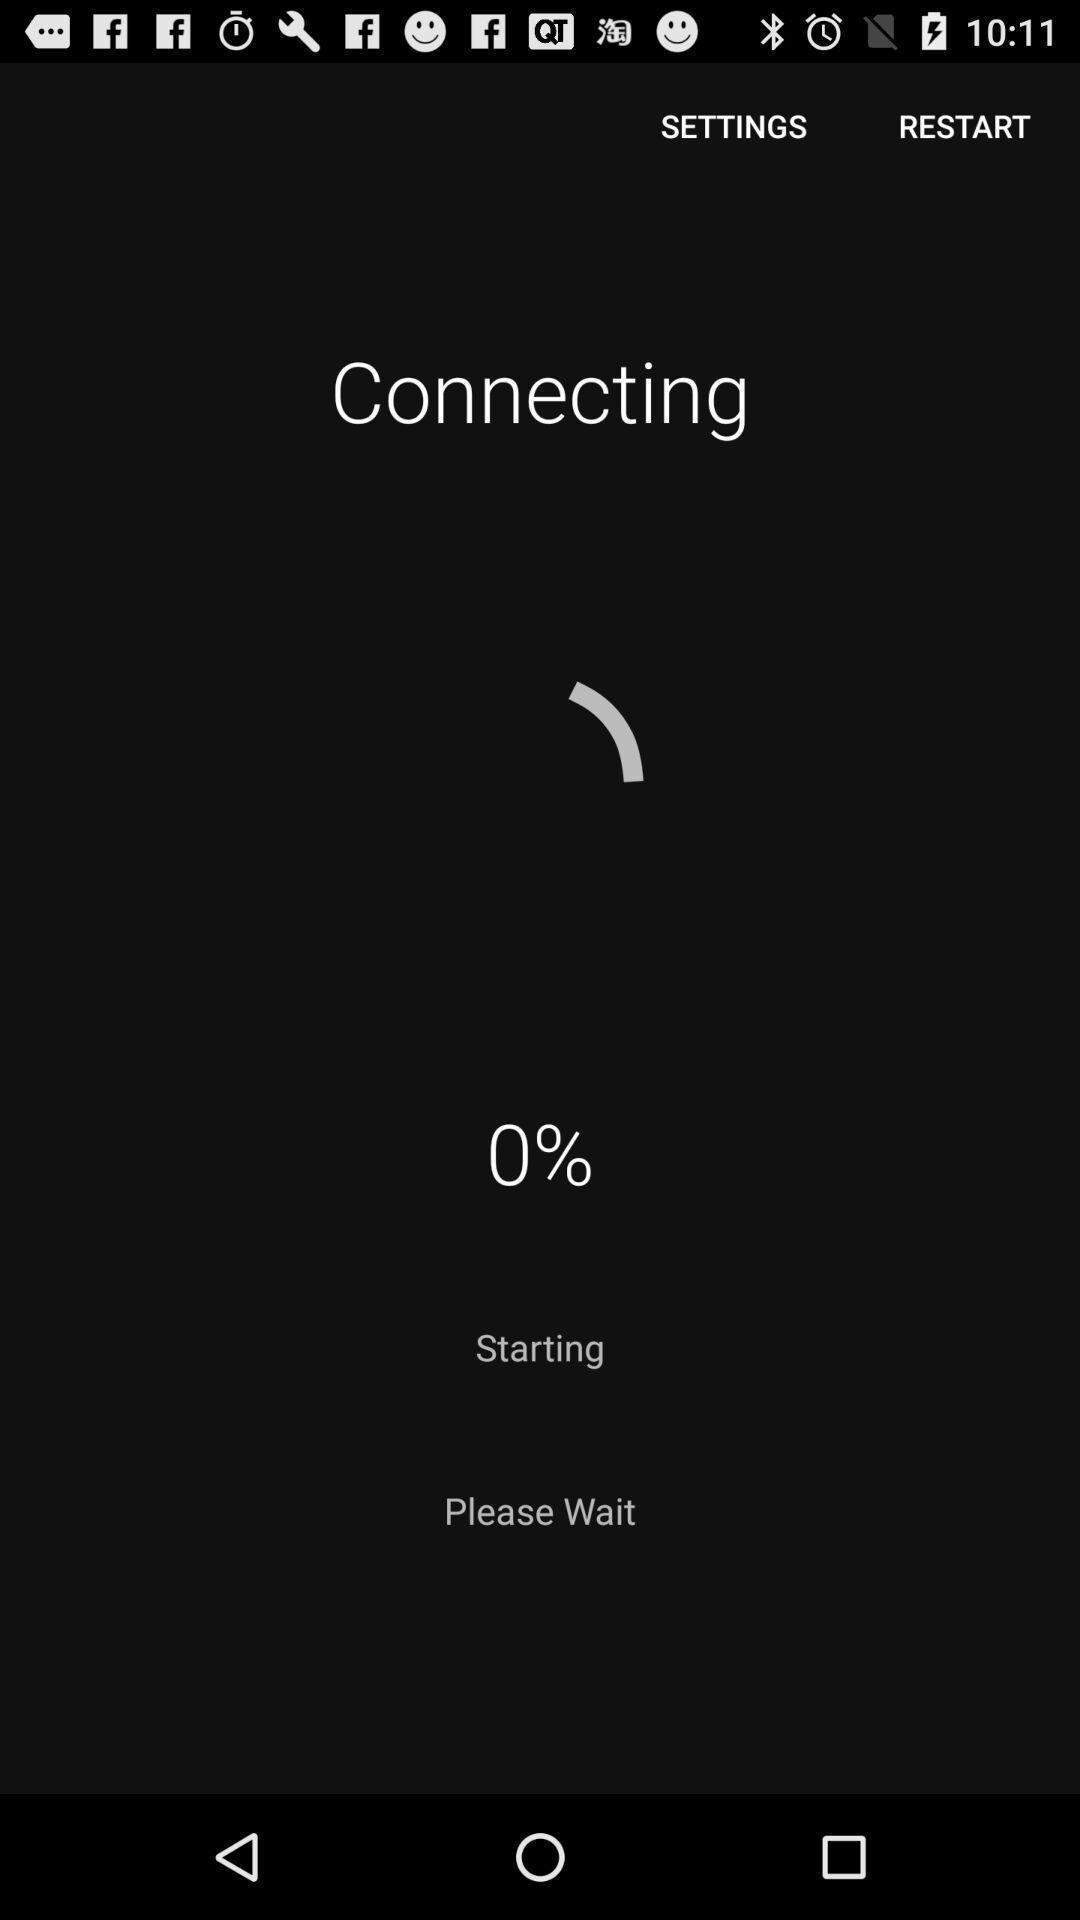What details can you identify in this image? Screen showing an app connecting through internet. 